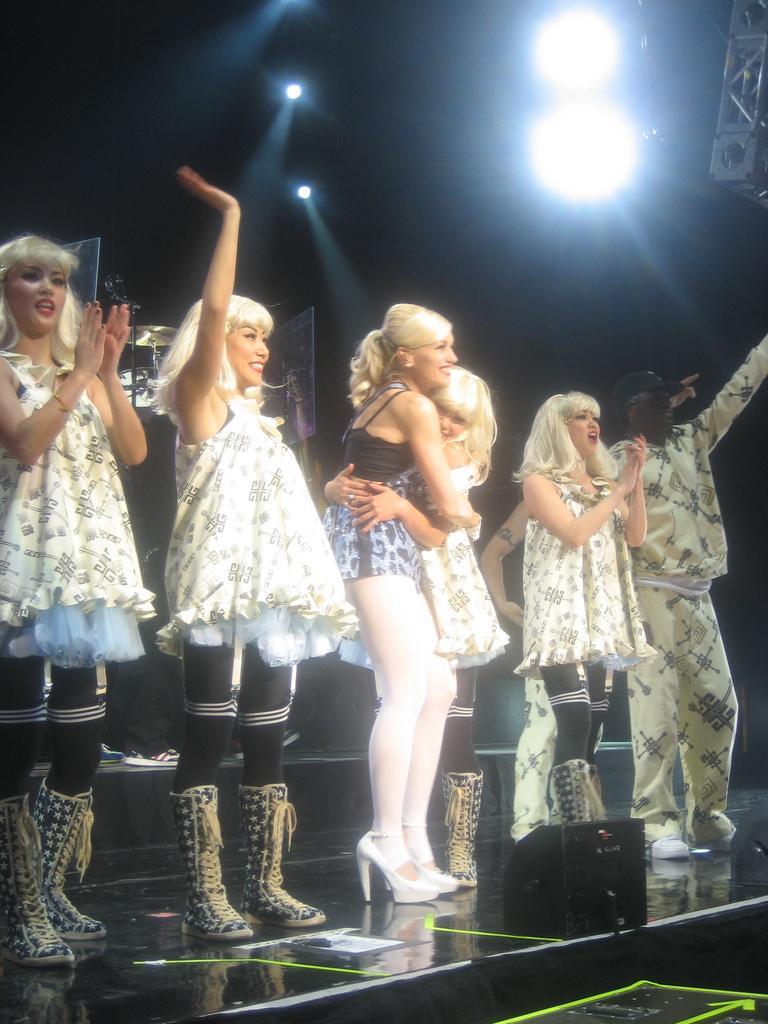Please provide a concise description of this image. In this picture we can see a group of people standing on the stage. In front of the people, there are some objects. Behind the people, there are musical instruments and a dark background. At the top of the image, there are lights. In the top right corner of the image, it looks like a truss. 